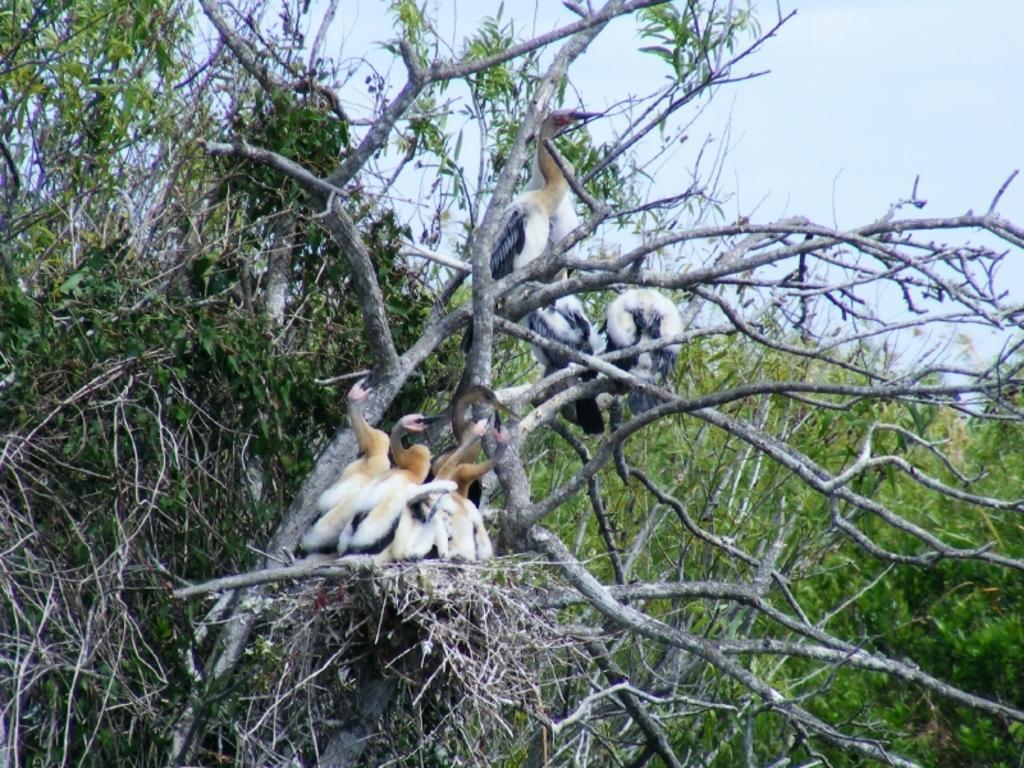In one or two sentences, can you explain what this image depicts? In this picture we can see some birds are on the trees. 